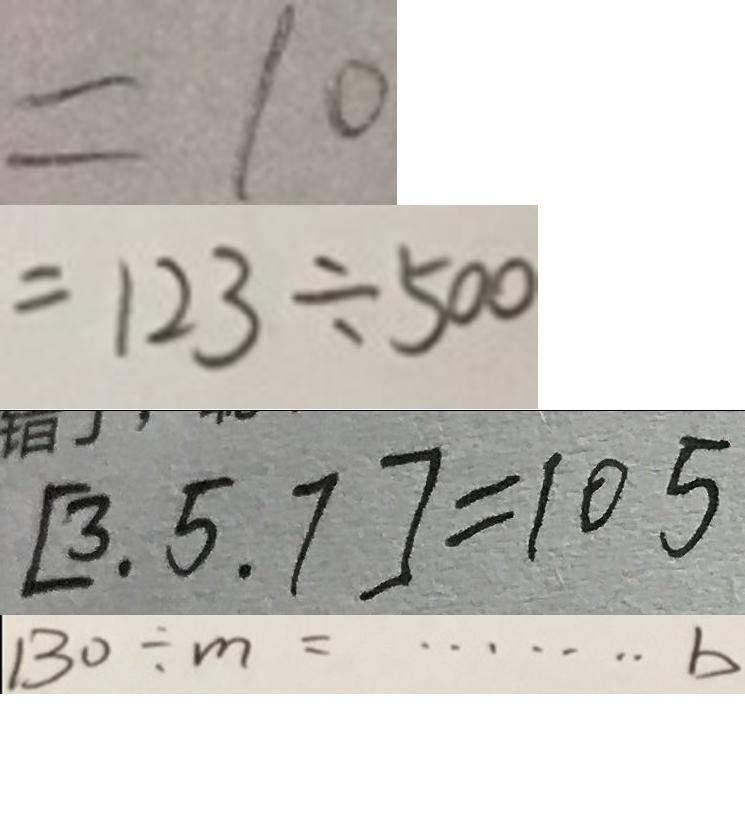Convert formula to latex. <formula><loc_0><loc_0><loc_500><loc_500>= 1 0 
 = 1 2 3 \div 5 0 0 
 [ 3 , 5 , 7 ] = 1 0 5 
 1 3 0 \div m = \cdots b</formula> 